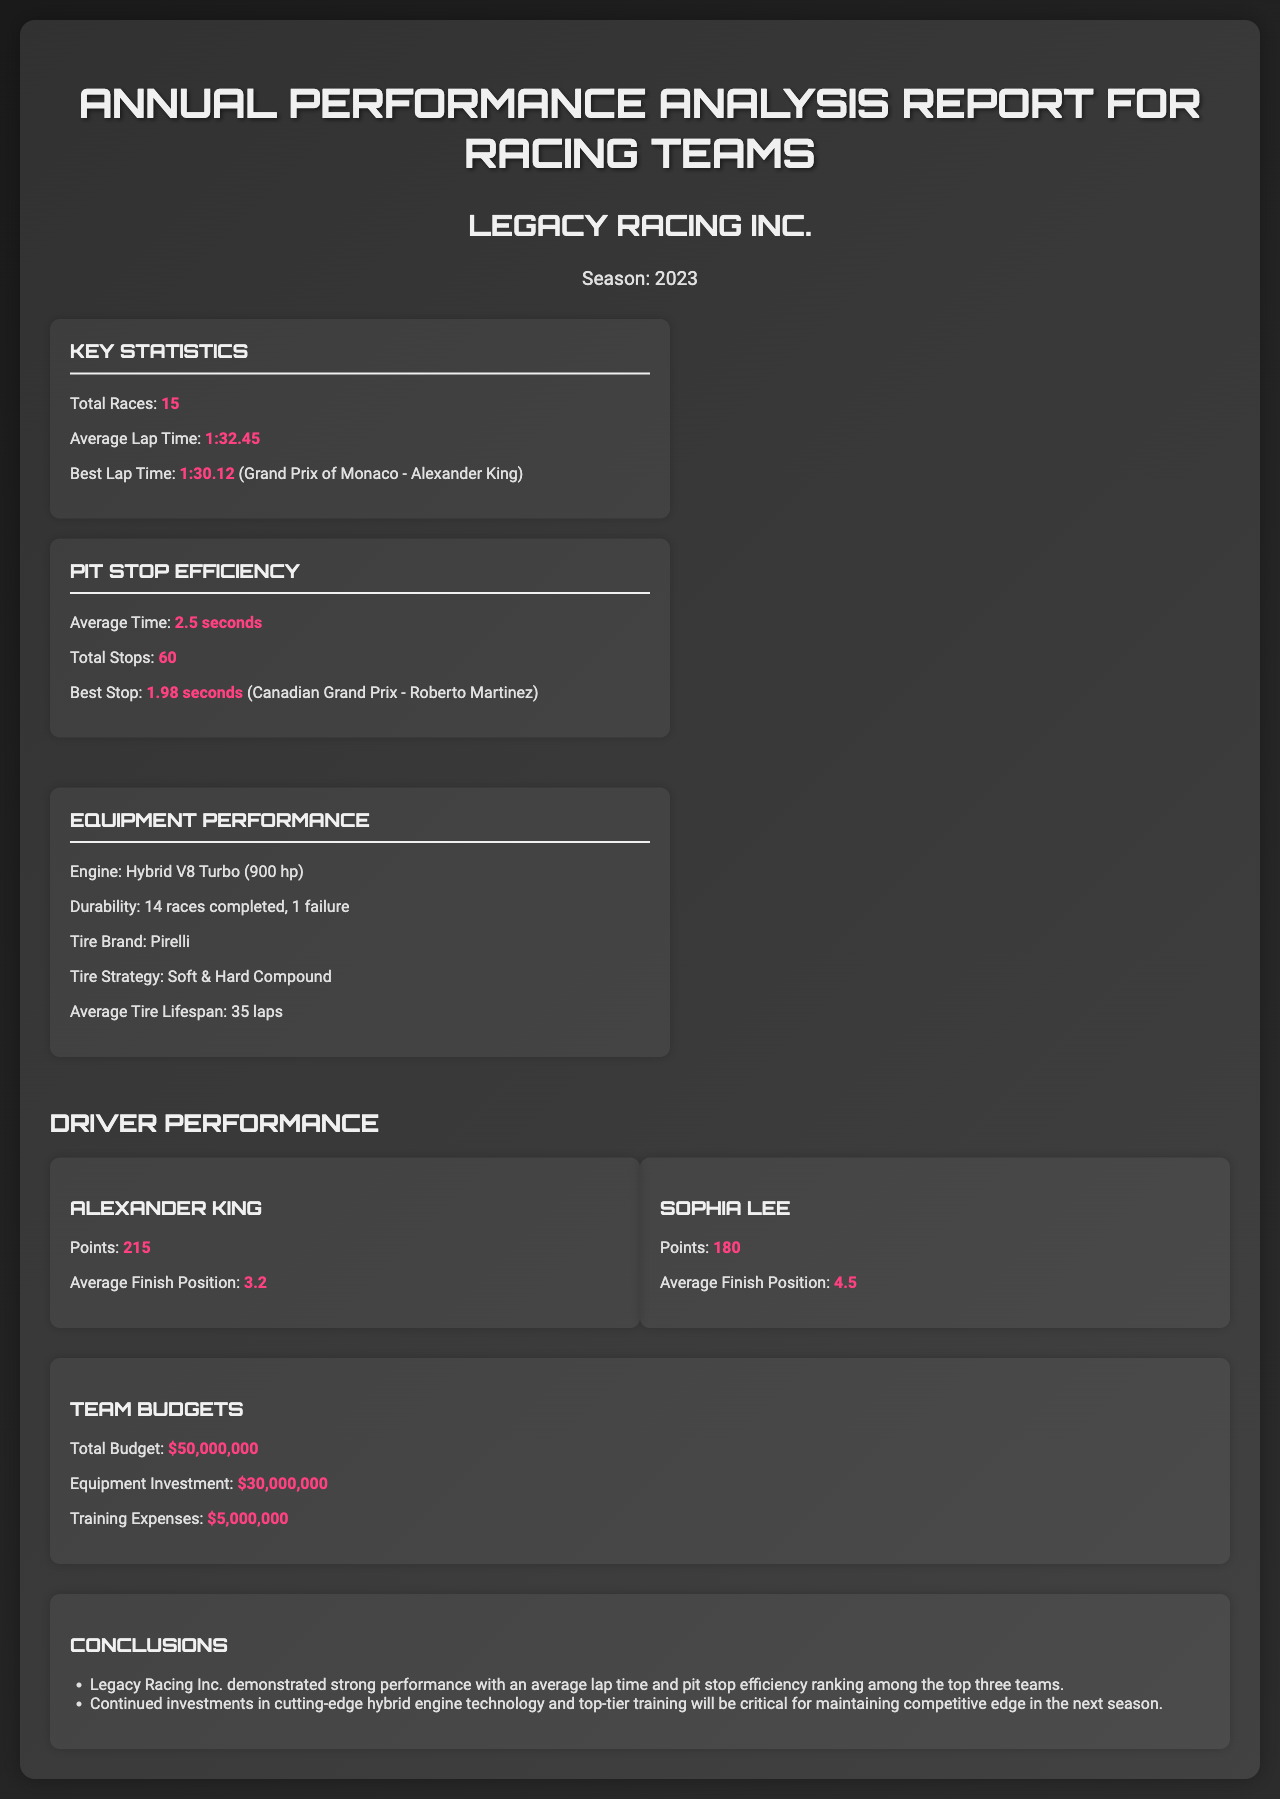What is the total number of races? The total number of races is listed in the document under Key Statistics.
Answer: 15 What is the best lap time? The best lap time is highlighted in the document, indicating the fastest recorded time for a lap.
Answer: 1:30.12 Who achieved the best lap time? The document specifies the driver who set the best lap time during the Grand Prix of Monaco.
Answer: Alexander King What is the average pit stop time? The average pit stop time is stated under the Pit Stop Efficiency section of the report.
Answer: 2.5 seconds What is the average finish position for Sophia Lee? This information is found under the Driver Performance section, where details about each driver are summarized.
Answer: 4.5 How many points did Alexander King earn? The document provides the total points earned by Alexander King in the Driver Performance section.
Answer: 215 What investment did Legacy Racing Inc. make in equipment? The total amount invested in equipment is outlined in the budget information section of the report.
Answer: $30,000,000 What was the average tire lifespan? The average tire lifespan is noted in the Equipment Performance section of the report.
Answer: 35 laps What is the engine type used by Legacy Racing Inc.? This specification is found under Equipment Performance, describing the engine utilized in the races.
Answer: Hybrid V8 Turbo 